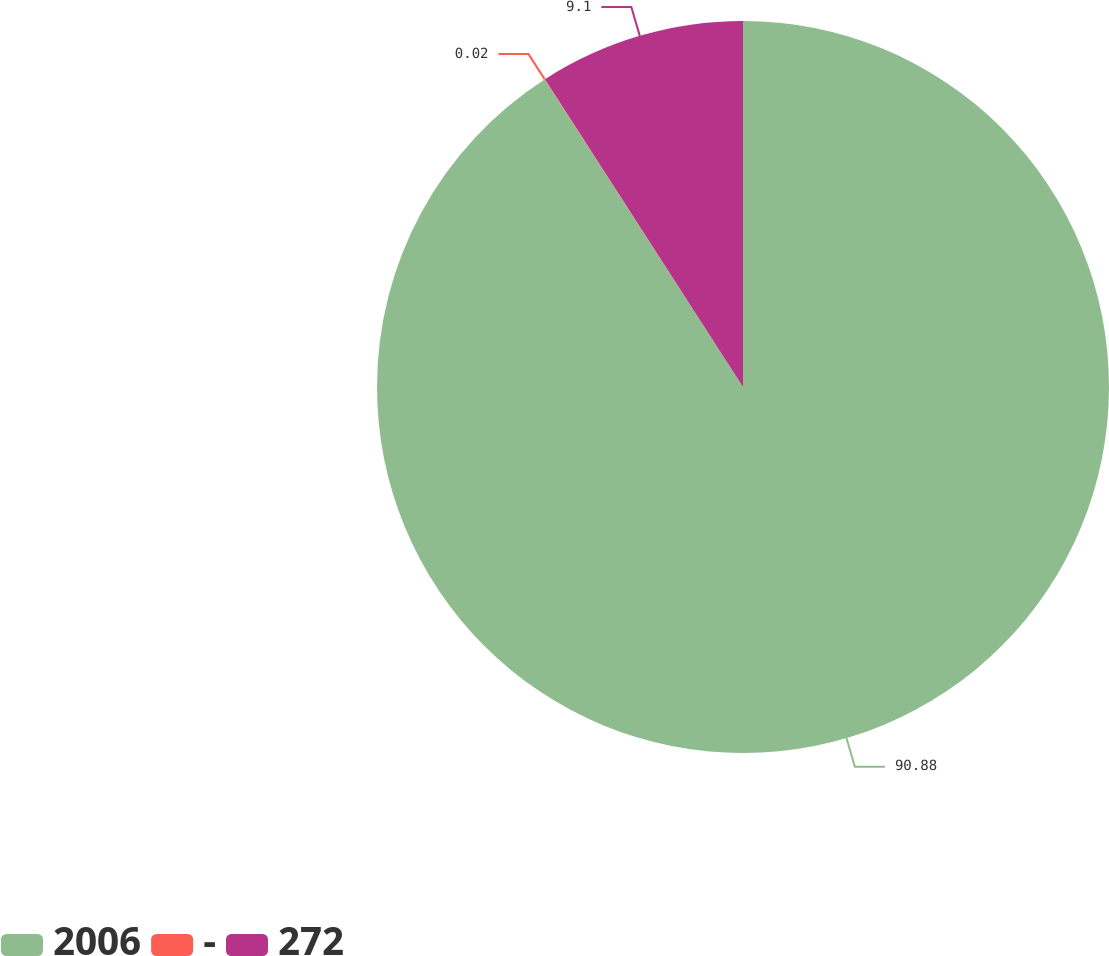<chart> <loc_0><loc_0><loc_500><loc_500><pie_chart><fcel>2006<fcel>-<fcel>272<nl><fcel>90.88%<fcel>0.02%<fcel>9.1%<nl></chart> 